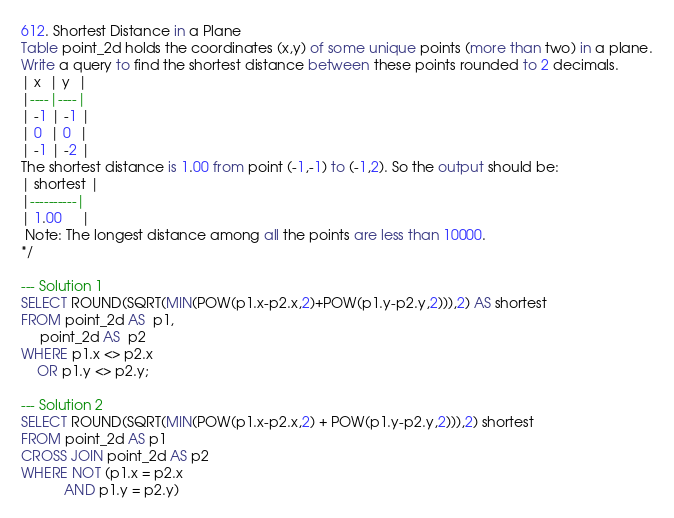<code> <loc_0><loc_0><loc_500><loc_500><_SQL_>612. Shortest Distance in a Plane
Table point_2d holds the coordinates (x,y) of some unique points (more than two) in a plane.
Write a query to find the shortest distance between these points rounded to 2 decimals.
| x  | y  |
|----|----|
| -1 | -1 |
| 0  | 0  |
| -1 | -2 |
The shortest distance is 1.00 from point (-1,-1) to (-1,2). So the output should be:
| shortest |
|----------|
| 1.00     |
 Note: The longest distance among all the points are less than 10000.
*/

--- Solution 1
SELECT ROUND(SQRT(MIN(POW(p1.x-p2.x,2)+POW(p1.y-p2.y,2))),2) AS shortest
FROM point_2d AS  p1,
     point_2d AS  p2
WHERE p1.x <> p2.x
    OR p1.y <> p2.y;
    
--- Solution 2    
SELECT ROUND(SQRT(MIN(POW(p1.x-p2.x,2) + POW(p1.y-p2.y,2))),2) shortest
FROM point_2d AS p1
CROSS JOIN point_2d AS p2
WHERE NOT (p1.x = p2.x
           AND p1.y = p2.y)

</code> 